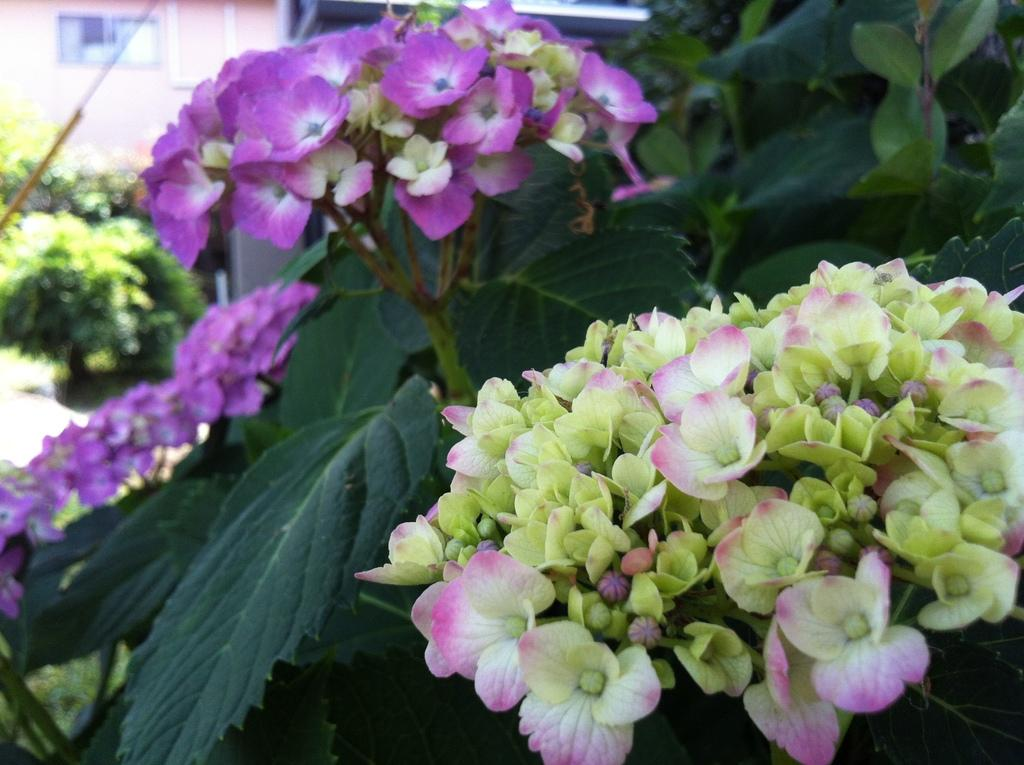What is present in the image? There is a plant in the image. What can be observed about the plant? The plant has flowers. What colors are the flowers? The flowers are pink and yellow in color. What can be seen in the distance in the image? There are houses visible in the background of the image. Can you describe the can that the giraffe is holding in the image? There is no giraffe or can present in the image; it features a plant with flowers and houses in the background. 